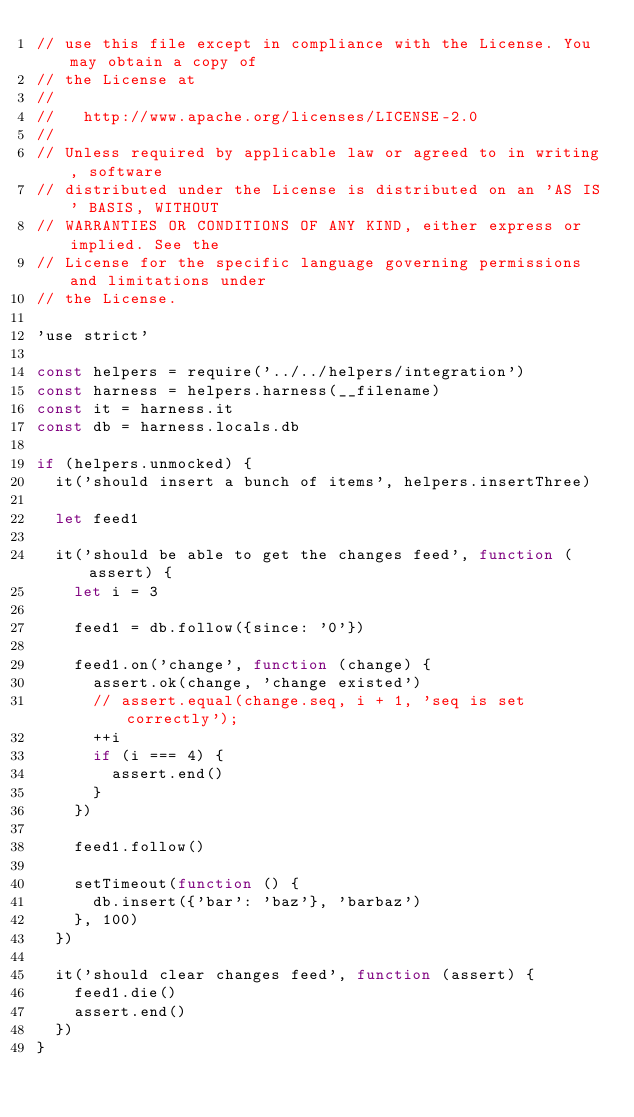Convert code to text. <code><loc_0><loc_0><loc_500><loc_500><_JavaScript_>// use this file except in compliance with the License. You may obtain a copy of
// the License at
//
//   http://www.apache.org/licenses/LICENSE-2.0
//
// Unless required by applicable law or agreed to in writing, software
// distributed under the License is distributed on an 'AS IS' BASIS, WITHOUT
// WARRANTIES OR CONDITIONS OF ANY KIND, either express or implied. See the
// License for the specific language governing permissions and limitations under
// the License.

'use strict'

const helpers = require('../../helpers/integration')
const harness = helpers.harness(__filename)
const it = harness.it
const db = harness.locals.db

if (helpers.unmocked) {
  it('should insert a bunch of items', helpers.insertThree)

  let feed1

  it('should be able to get the changes feed', function (assert) {
    let i = 3

    feed1 = db.follow({since: '0'})

    feed1.on('change', function (change) {
      assert.ok(change, 'change existed')
      // assert.equal(change.seq, i + 1, 'seq is set correctly');
      ++i
      if (i === 4) {
        assert.end()
      }
    })

    feed1.follow()

    setTimeout(function () {
      db.insert({'bar': 'baz'}, 'barbaz')
    }, 100)
  })

  it('should clear changes feed', function (assert) {
    feed1.die()
    assert.end()
  })
}
</code> 